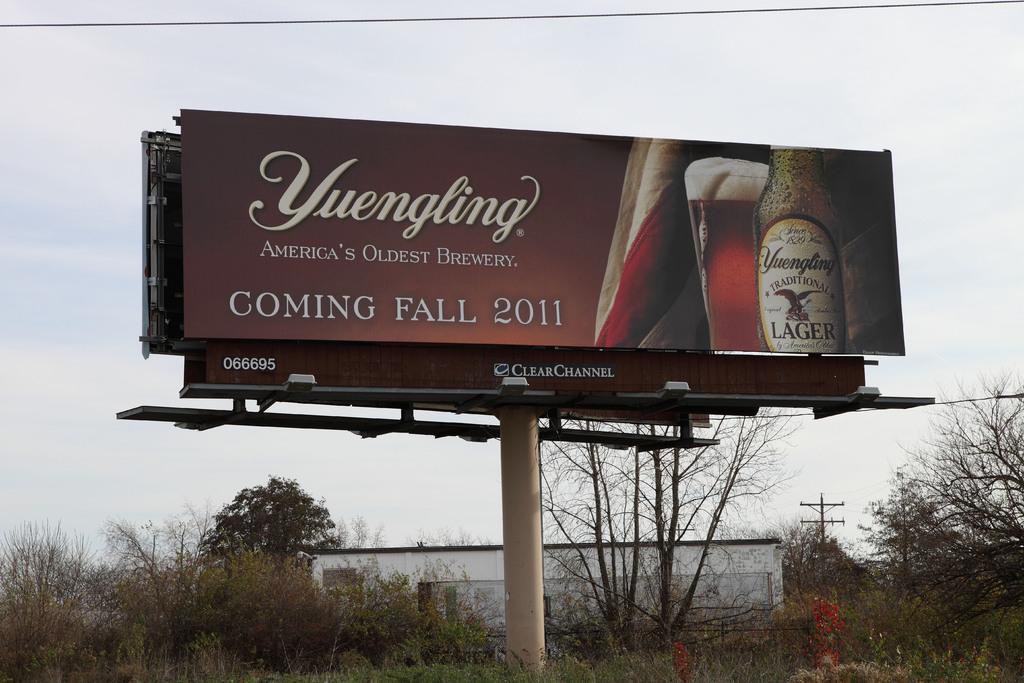Could you give a brief overview of what you see in this image? In the image there is a pole with advertising hoarding. And on the ground there is grass and also there are small plants and trees. Behind them there is a building with roof and wall. And in the background there is sky. 